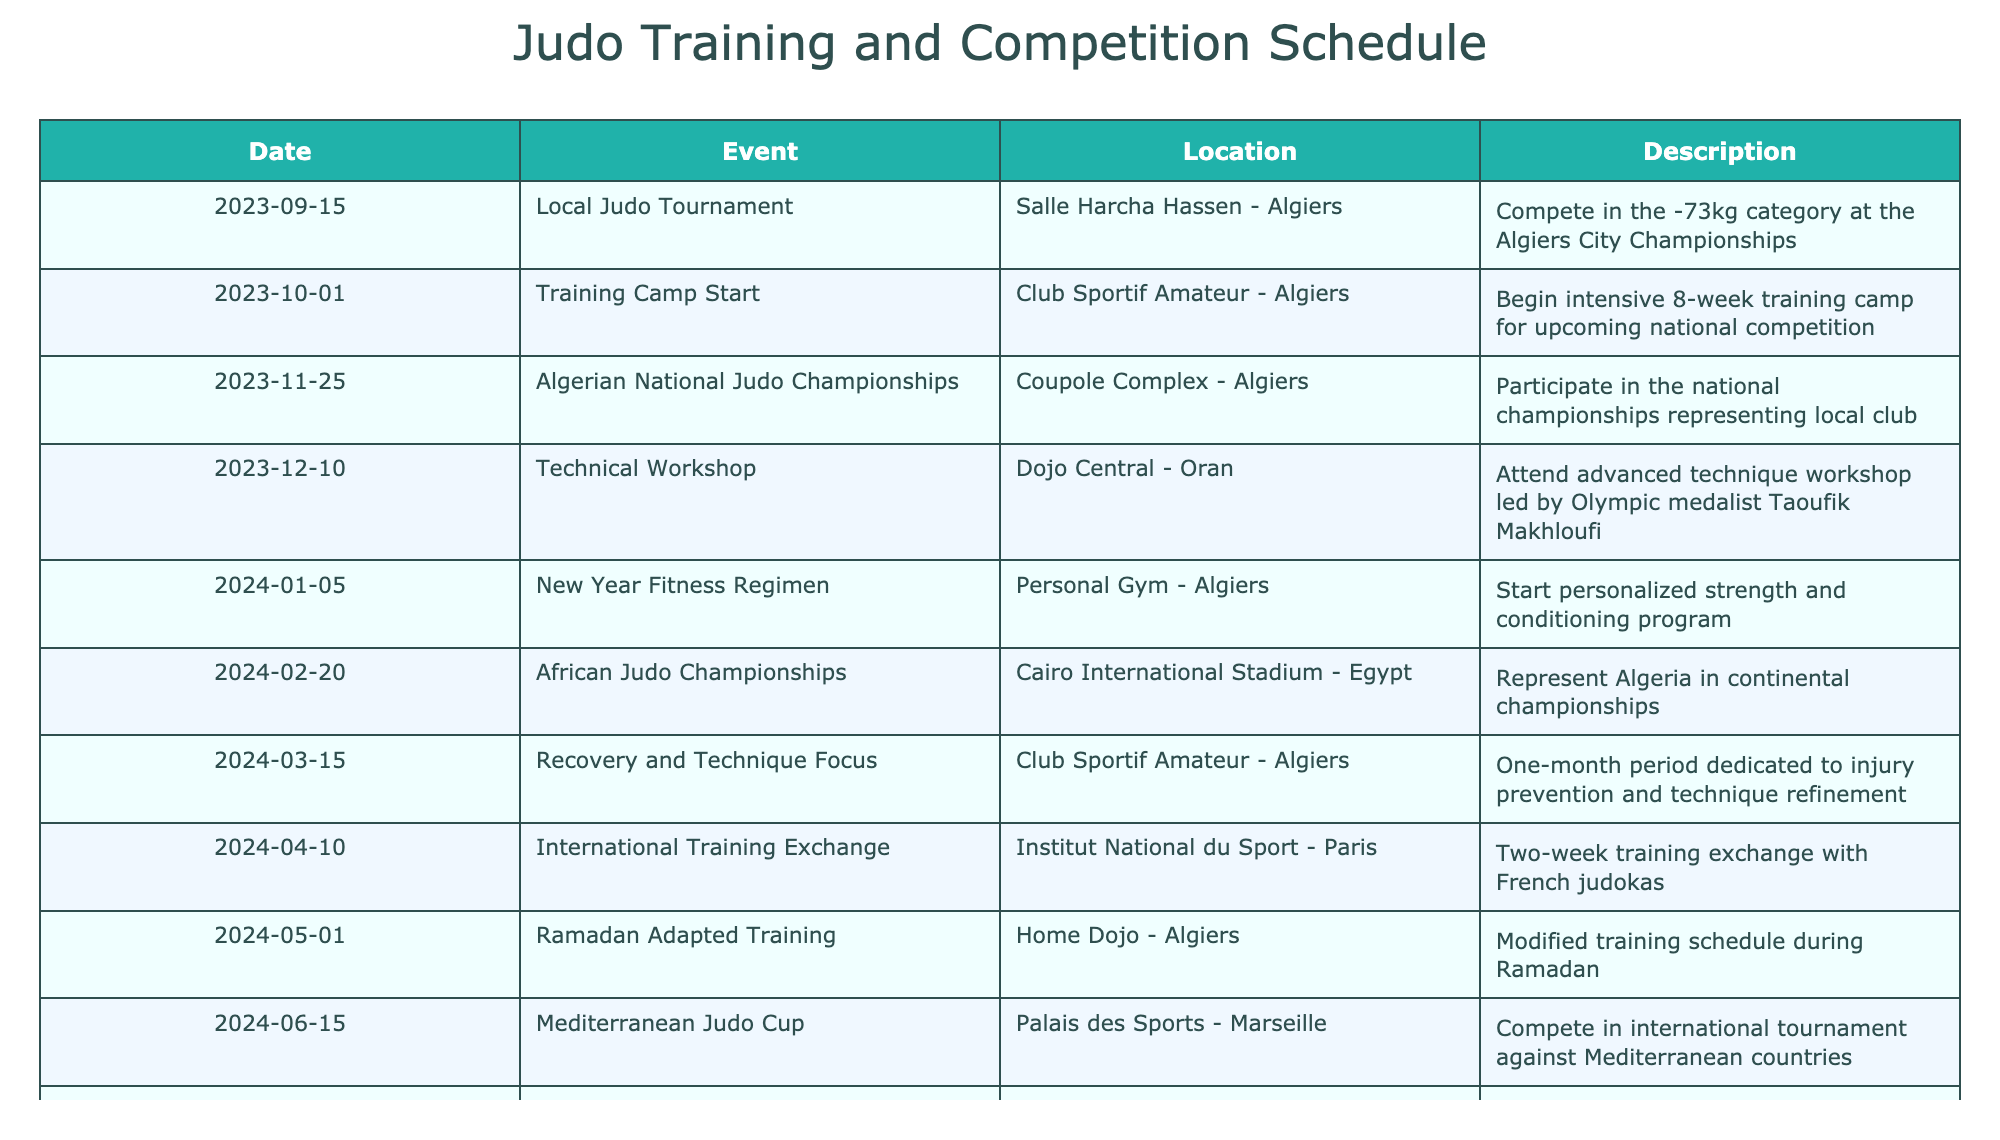What is the date of the Local Judo Tournament? Referring to the table, the Local Judo Tournament is listed under the 'Date' column with the date '2023-09-15'.
Answer: 2023-09-15 How many judo events are scheduled between October 2023 and April 2024? The events scheduled during that period are the Training Camp Start on 2023-10-01, the Algerian National Judo Championships on 2023-11-25, the Technical Workshop on 2023-12-10, the New Year Fitness Regimen on 2024-01-05, the African Judo Championships on 2024-02-20, and the Recovery and Technique Focus on 2024-03-15. Counting these gives us 6 events.
Answer: 6 Is the International Training Exchange happening in Algiers? The International Training Exchange is scheduled at the Institut National du Sport in Paris, not in Algiers.
Answer: No What event occurs immediately after the Technical Workshop? The Technical Workshop takes place on 2023-12-10, and the very next event listed is the New Year Fitness Regimen on 2024-01-05.
Answer: New Year Fitness Regimen How many days are there between the Algerian National Judo Championships and the African Judo Championships? The Algerian National Judo Championships occur on 2023-11-25 and the African Judo Championships on 2024-02-20. The difference in days can be calculated by finding the number of days between these two dates, which is 86 days.
Answer: 86 days What will be the focus of the training from March 15, 2024? According to the table, the focus of the training starting March 15, 2024, will be on Recovery and Technique Focus.
Answer: Recovery and Technique Focus Is there any event scheduled after the Mediterranean Judo Cup? The Mediterranean Judo Cup is on 2024-06-15, and the next event listed is the Olympic Qualification Tournament on 2024-07-20. This confirms there is an event following it.
Answer: Yes What is the last event scheduled in the timeline? The table lists the last event as Post-Tournament Recovery on 2024-08-05.
Answer: Post-Tournament Recovery 